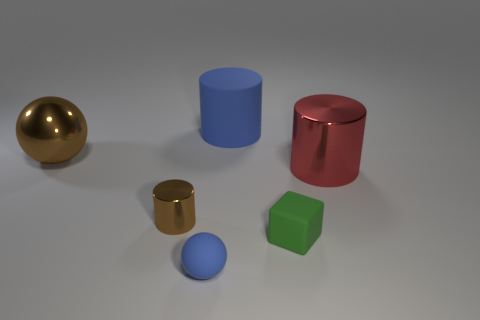Does the green matte object have the same size as the shiny cylinder that is left of the big blue object?
Give a very brief answer. Yes. How many other things are the same color as the tiny block?
Make the answer very short. 0. Is the number of large brown metal spheres in front of the big brown metal sphere greater than the number of tiny green matte things?
Offer a terse response. No. There is a shiny cylinder on the right side of the tiny rubber object in front of the rubber object right of the blue cylinder; what is its color?
Your answer should be very brief. Red. Is the large red object made of the same material as the brown cylinder?
Your answer should be compact. Yes. Are there any blue objects of the same size as the rubber ball?
Your response must be concise. No. There is a brown object that is the same size as the cube; what is it made of?
Offer a very short reply. Metal. Are there any large brown objects of the same shape as the tiny shiny thing?
Your answer should be compact. No. There is a large thing that is the same color as the tiny matte ball; what is it made of?
Give a very brief answer. Rubber. What is the shape of the big metal object that is left of the big blue rubber object?
Offer a very short reply. Sphere. 